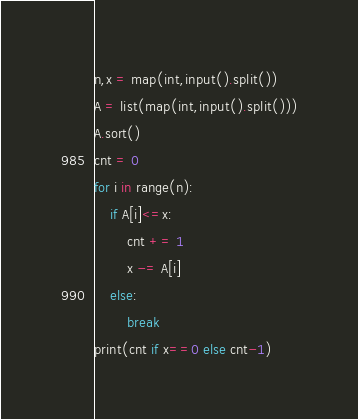Convert code to text. <code><loc_0><loc_0><loc_500><loc_500><_Python_>n,x = map(int,input().split())
A = list(map(int,input().split()))
A.sort()
cnt = 0
for i in range(n):
    if A[i]<=x:
        cnt += 1
        x -= A[i]
    else:
        break
print(cnt if x==0 else cnt-1)</code> 